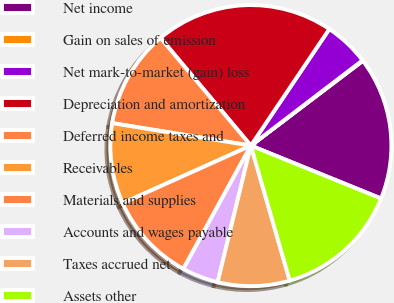Convert chart. <chart><loc_0><loc_0><loc_500><loc_500><pie_chart><fcel>Net income<fcel>Gain on sales of emission<fcel>Net mark-to-market (gain) loss<fcel>Depreciation and amortization<fcel>Deferred income taxes and<fcel>Receivables<fcel>Materials and supplies<fcel>Accounts and wages payable<fcel>Taxes accrued net<fcel>Assets other<nl><fcel>16.45%<fcel>0.07%<fcel>5.19%<fcel>20.54%<fcel>11.33%<fcel>9.28%<fcel>10.31%<fcel>4.17%<fcel>8.26%<fcel>14.4%<nl></chart> 